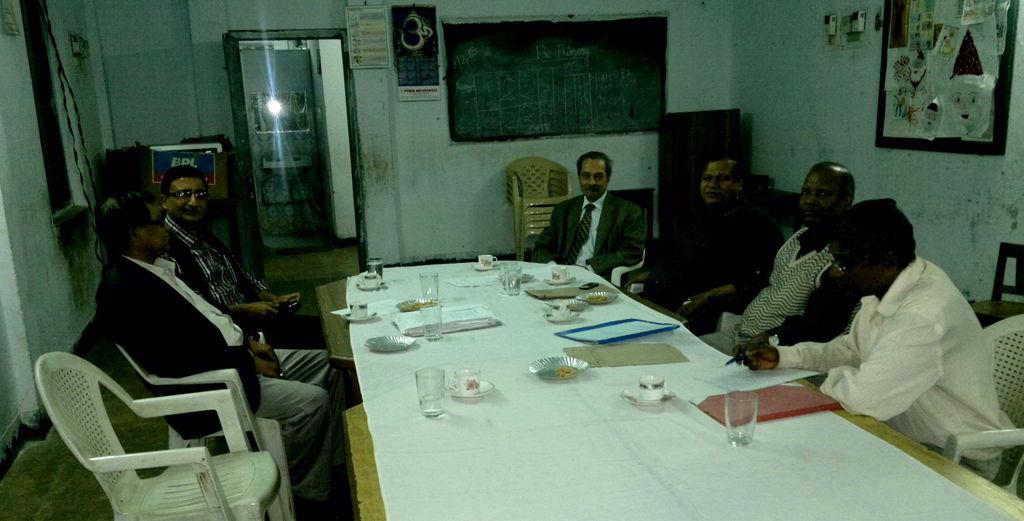What are the people in the image doing? The people in the image are sitting on chairs. What is in front of the chairs? There is a table in front of the chairs. What objects can be seen on the table? There is a glass, a cup, a soccer ball, and a plate on the table. What is on the plate? There are food items on the plate. What type of paint is being used to decorate the birthday cake on the table? There is no birthday cake present in the image, and therefore no paint or decoration can be observed. 